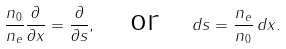Convert formula to latex. <formula><loc_0><loc_0><loc_500><loc_500>\frac { n _ { 0 } } { n _ { e } } \frac { \partial } { \partial x } = \frac { \partial } { \partial s } , \quad \text {or} \quad d s = \frac { n _ { e } } { n _ { 0 } } \, d x .</formula> 